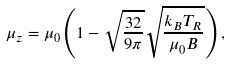<formula> <loc_0><loc_0><loc_500><loc_500>\mu _ { z } = \mu _ { 0 } \left ( 1 - \sqrt { \frac { 3 2 } { 9 \pi } } \sqrt { \frac { { k _ { B } } T _ { R } } { \mu _ { 0 } B } } \right ) ,</formula> 